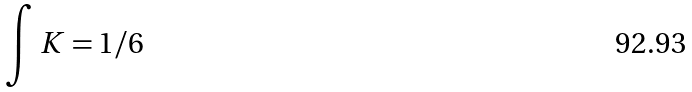Convert formula to latex. <formula><loc_0><loc_0><loc_500><loc_500>\int K = 1 / 6</formula> 